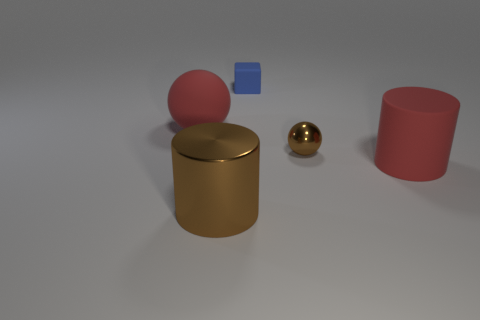There is a object that is the same color as the big rubber sphere; what is its material?
Offer a terse response. Rubber. Is there a thing that has the same size as the brown cylinder?
Give a very brief answer. Yes. There is a ball that is left of the cube; is it the same color as the big metal thing?
Give a very brief answer. No. There is a object that is both in front of the tiny ball and right of the small blue rubber object; what is its color?
Make the answer very short. Red. There is a matte object that is the same size as the metallic sphere; what shape is it?
Your answer should be compact. Cube. Is there a brown thing that has the same shape as the tiny blue matte object?
Ensure brevity in your answer.  No. There is a red object behind the brown ball; is its size the same as the large brown cylinder?
Ensure brevity in your answer.  Yes. There is a object that is both behind the brown sphere and on the right side of the big metallic thing; what is its size?
Your response must be concise. Small. What number of other objects are the same material as the tiny brown object?
Ensure brevity in your answer.  1. There is a sphere to the left of the small blue rubber thing; what is its size?
Provide a succinct answer. Large. 